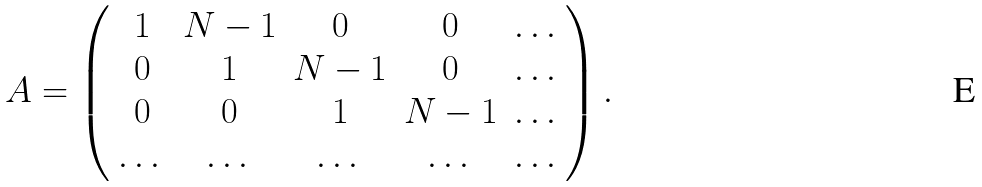Convert formula to latex. <formula><loc_0><loc_0><loc_500><loc_500>A = \left ( \begin{array} { c c c c c } 1 & N - 1 & 0 & 0 & \dots \\ 0 & 1 & N - 1 & 0 & \dots \\ 0 & 0 & 1 & N - 1 & \dots \\ \dots & \dots & \dots & \dots & \dots \end{array} \right ) .</formula> 